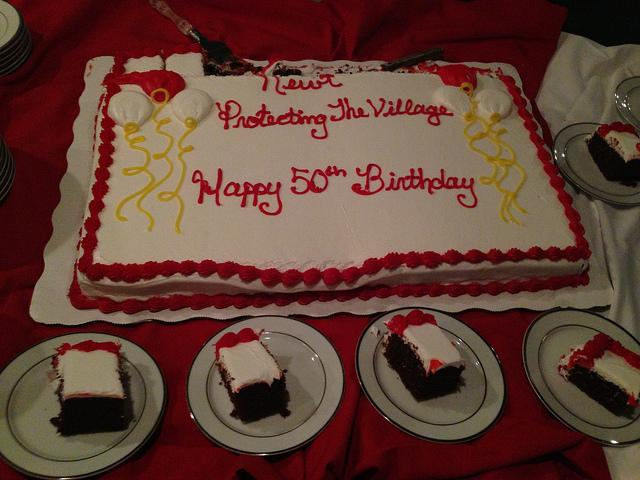The birthday boy has a name that refers to what kind of animal?

Choices:
A) salamander
B) cat
C) dog
D) bird salamander 